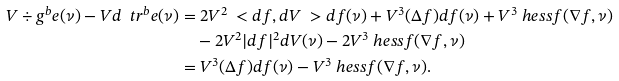<formula> <loc_0><loc_0><loc_500><loc_500>V \div g ^ { b } e ( \nu ) - V d \ t r ^ { b } e ( \nu ) & = 2 V ^ { 2 } \ < d f , d V \ > d f ( \nu ) + V ^ { 3 } ( \Delta f ) d f ( \nu ) + V ^ { 3 } \ h e s s f ( \nabla f , \nu ) \\ & \quad - 2 V ^ { 2 } | d f | ^ { 2 } d V ( \nu ) - 2 V ^ { 3 } \ h e s s f ( \nabla f , \nu ) \\ & = V ^ { 3 } ( \Delta f ) d f ( \nu ) - V ^ { 3 } \ h e s s f ( \nabla f , \nu ) .</formula> 